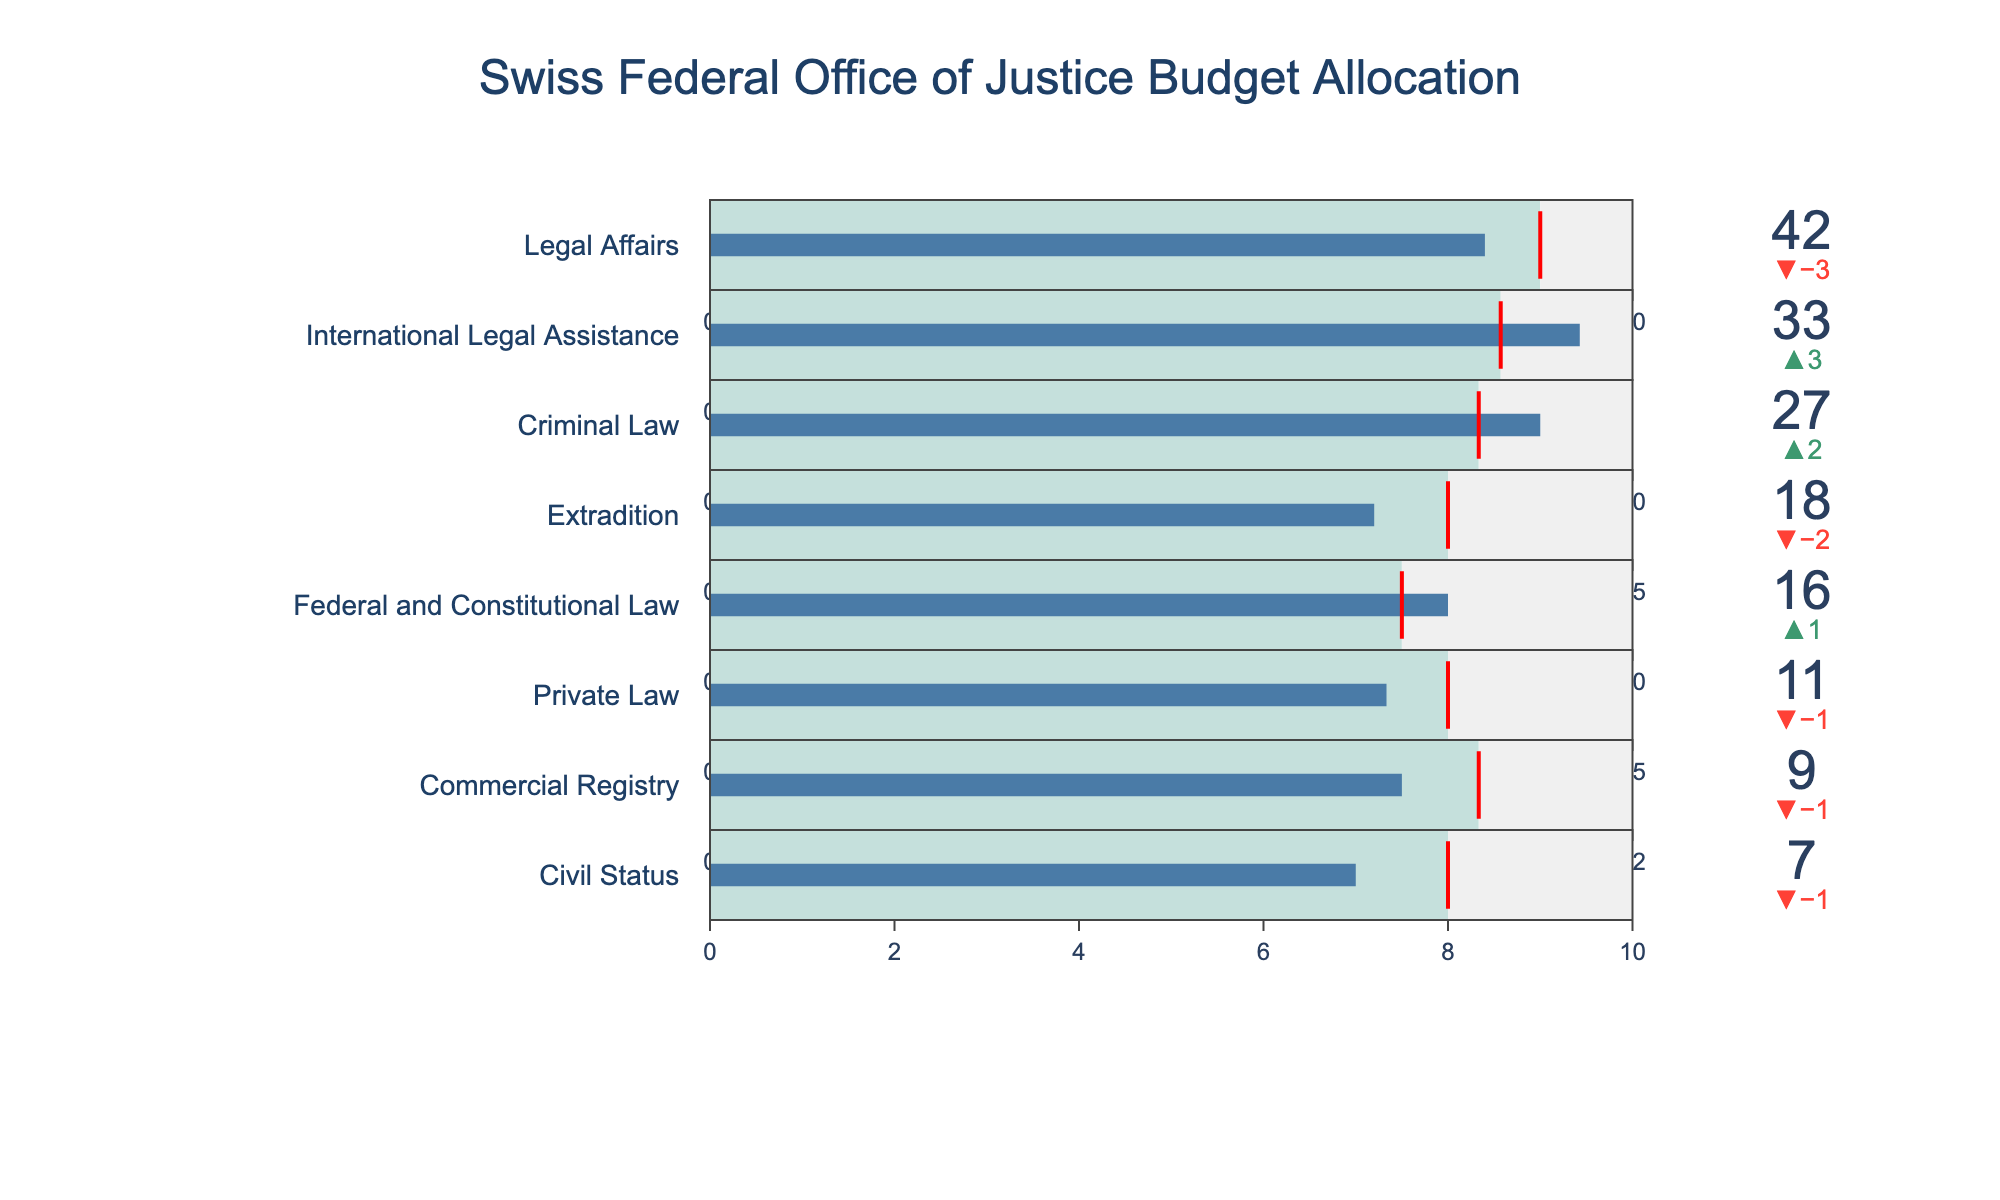What is the actual spending by the Legal Affairs department? According to the figure, the Actual Spending is indicated directly on the bar corresponding to the Legal Affairs department.
Answer: 42 Which department exceeded its Planned Budget by the highest amount? By comparing the delta values near each bar, the International Legal Assistance department exceeded its Planned Budget (30) by 3, with an Actual Spending of 33.
Answer: International Legal Assistance How does the Actual Spending in the Extradition department compare to its Planned Budget? By observing the Extradition bar, the Actual Spending (18) is 2 units lower than the Planned Budget (20), indicated by the delta.
Answer: 2 units lower What is the difference between the Maximum Budget and the Actual Spending for the Criminal Law department? The Criminal Law department has a Maximum Budget of 30 and an Actual Spending of 27, so the difference is calculated as 30 - 27.
Answer: 3 Which department has the lowest Actual Spending? By scanning the Actual Spending values across all departments, the Civil Status department has the lowest at 7.
Answer: Civil Status Is there any department where the Actual Spending is exactly equal to the Planned Budget? By examining the delta values, none of the departments show a delta of zero, which means none have Actual Spending exactly equal to the Planned Budget.
Answer: No What is the combined actual spending of Legal Affairs and Criminal Law departments? The Actual Spending for Legal Affairs is 42 and for Criminal Law is 27. Summing these amounts results in 42 + 27.
Answer: 69 How much did the Private Law department spend compared to its Maximum Budget? The Actual Spending of the Private Law department is 11, and the Maximum Budget is 15. The comparison shows that it spent 15 - 11, which equals 4 units less than its Maximum Budget.
Answer: 4 units less Which department came closest to its Maximum Budget? By comparing the Maximum Budget and Actual Spending, the International Legal Assistance with a Maximum Budget of 35 and Actual Spending of 33 is the closest.
Answer: International Legal Assistance What is the average of the Planned Budgets across all departments? Adding up all Planned Budgets (45 + 30 + 25 + 20 + 15 + 12 + 10 + 8) equals 165. Dividing by the number of departments (8), the average is 165 / 8.
Answer: 20.625 